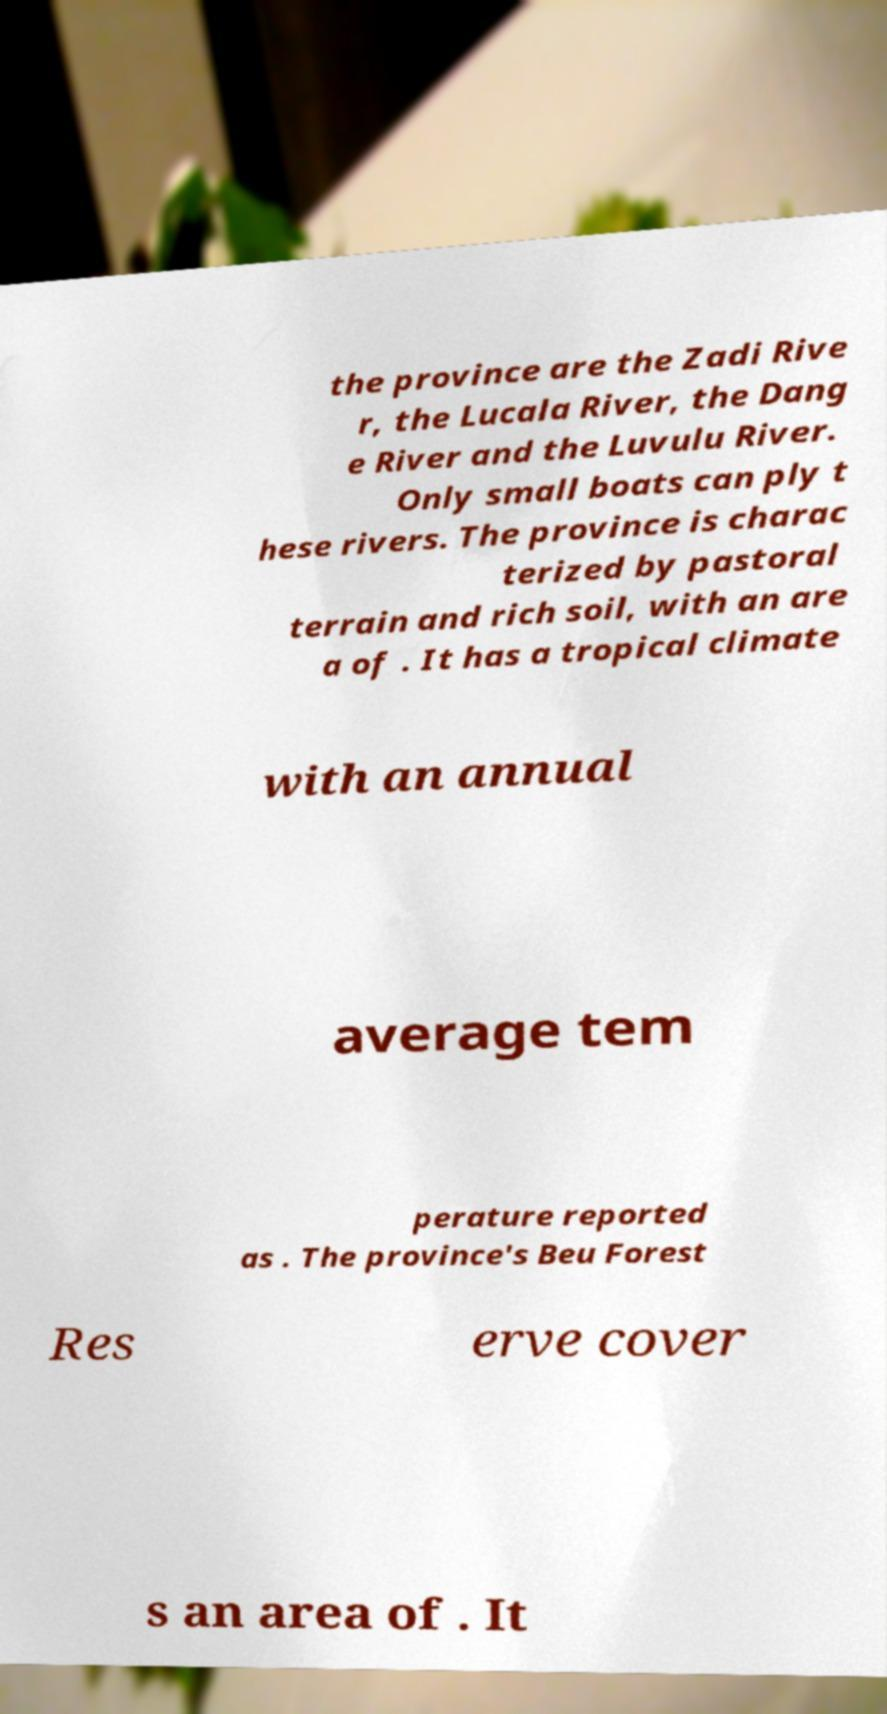Can you read and provide the text displayed in the image?This photo seems to have some interesting text. Can you extract and type it out for me? the province are the Zadi Rive r, the Lucala River, the Dang e River and the Luvulu River. Only small boats can ply t hese rivers. The province is charac terized by pastoral terrain and rich soil, with an are a of . It has a tropical climate with an annual average tem perature reported as . The province's Beu Forest Res erve cover s an area of . It 